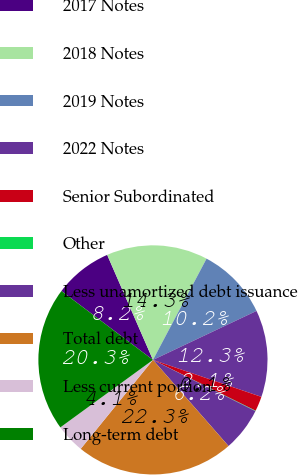Convert chart to OTSL. <chart><loc_0><loc_0><loc_500><loc_500><pie_chart><fcel>2017 Notes<fcel>2018 Notes<fcel>2019 Notes<fcel>2022 Notes<fcel>Senior Subordinated<fcel>Other<fcel>Less unamortized debt issuance<fcel>Total debt<fcel>Less current portion<fcel>Long-term debt<nl><fcel>8.19%<fcel>14.29%<fcel>10.22%<fcel>12.26%<fcel>2.09%<fcel>0.06%<fcel>6.16%<fcel>22.32%<fcel>4.12%<fcel>20.29%<nl></chart> 